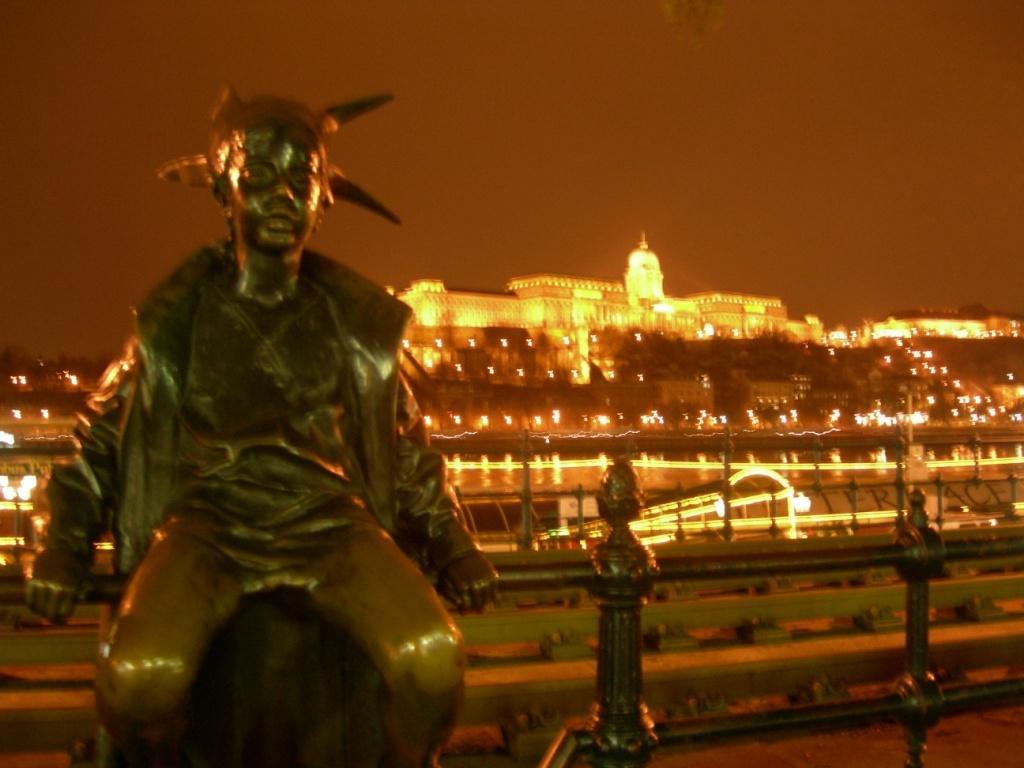Could you give a brief overview of what you see in this image? In this image there is a statue on a iron grill, in the background there are buildings with lighting. 